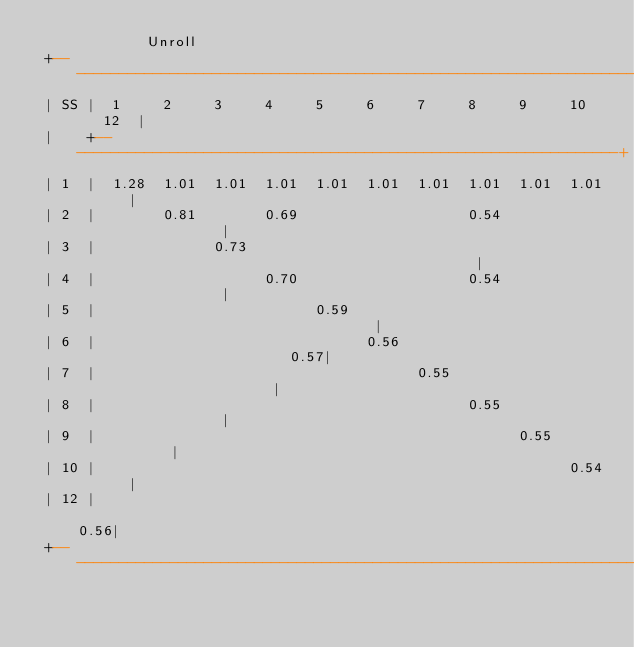<code> <loc_0><loc_0><loc_500><loc_500><_SQL_>             Unroll
 +-----------------------------------------------------------------------+
 | SS |  1     2     3     4     5     6     7     8     9     10    12  |
 |    +------------------------------------------------------------------+
 | 1  |  1.28  1.01  1.01  1.01  1.01  1.01  1.01  1.01  1.01  1.01      |
 | 2  |        0.81        0.69                    0.54                  |
 | 3  |              0.73                                                |
 | 4  |                    0.70                    0.54                  |
 | 5  |                          0.59                                    |
 | 6  |                                0.56                          0.57|
 | 7  |                                      0.55                        |
 | 8  |                                            0.55                  |
 | 9  |                                                  0.55            |
 | 10 |                                                        0.54      |
 | 12 |                                                              0.56|
 +-----------------------------------------------------------------------+
</code> 